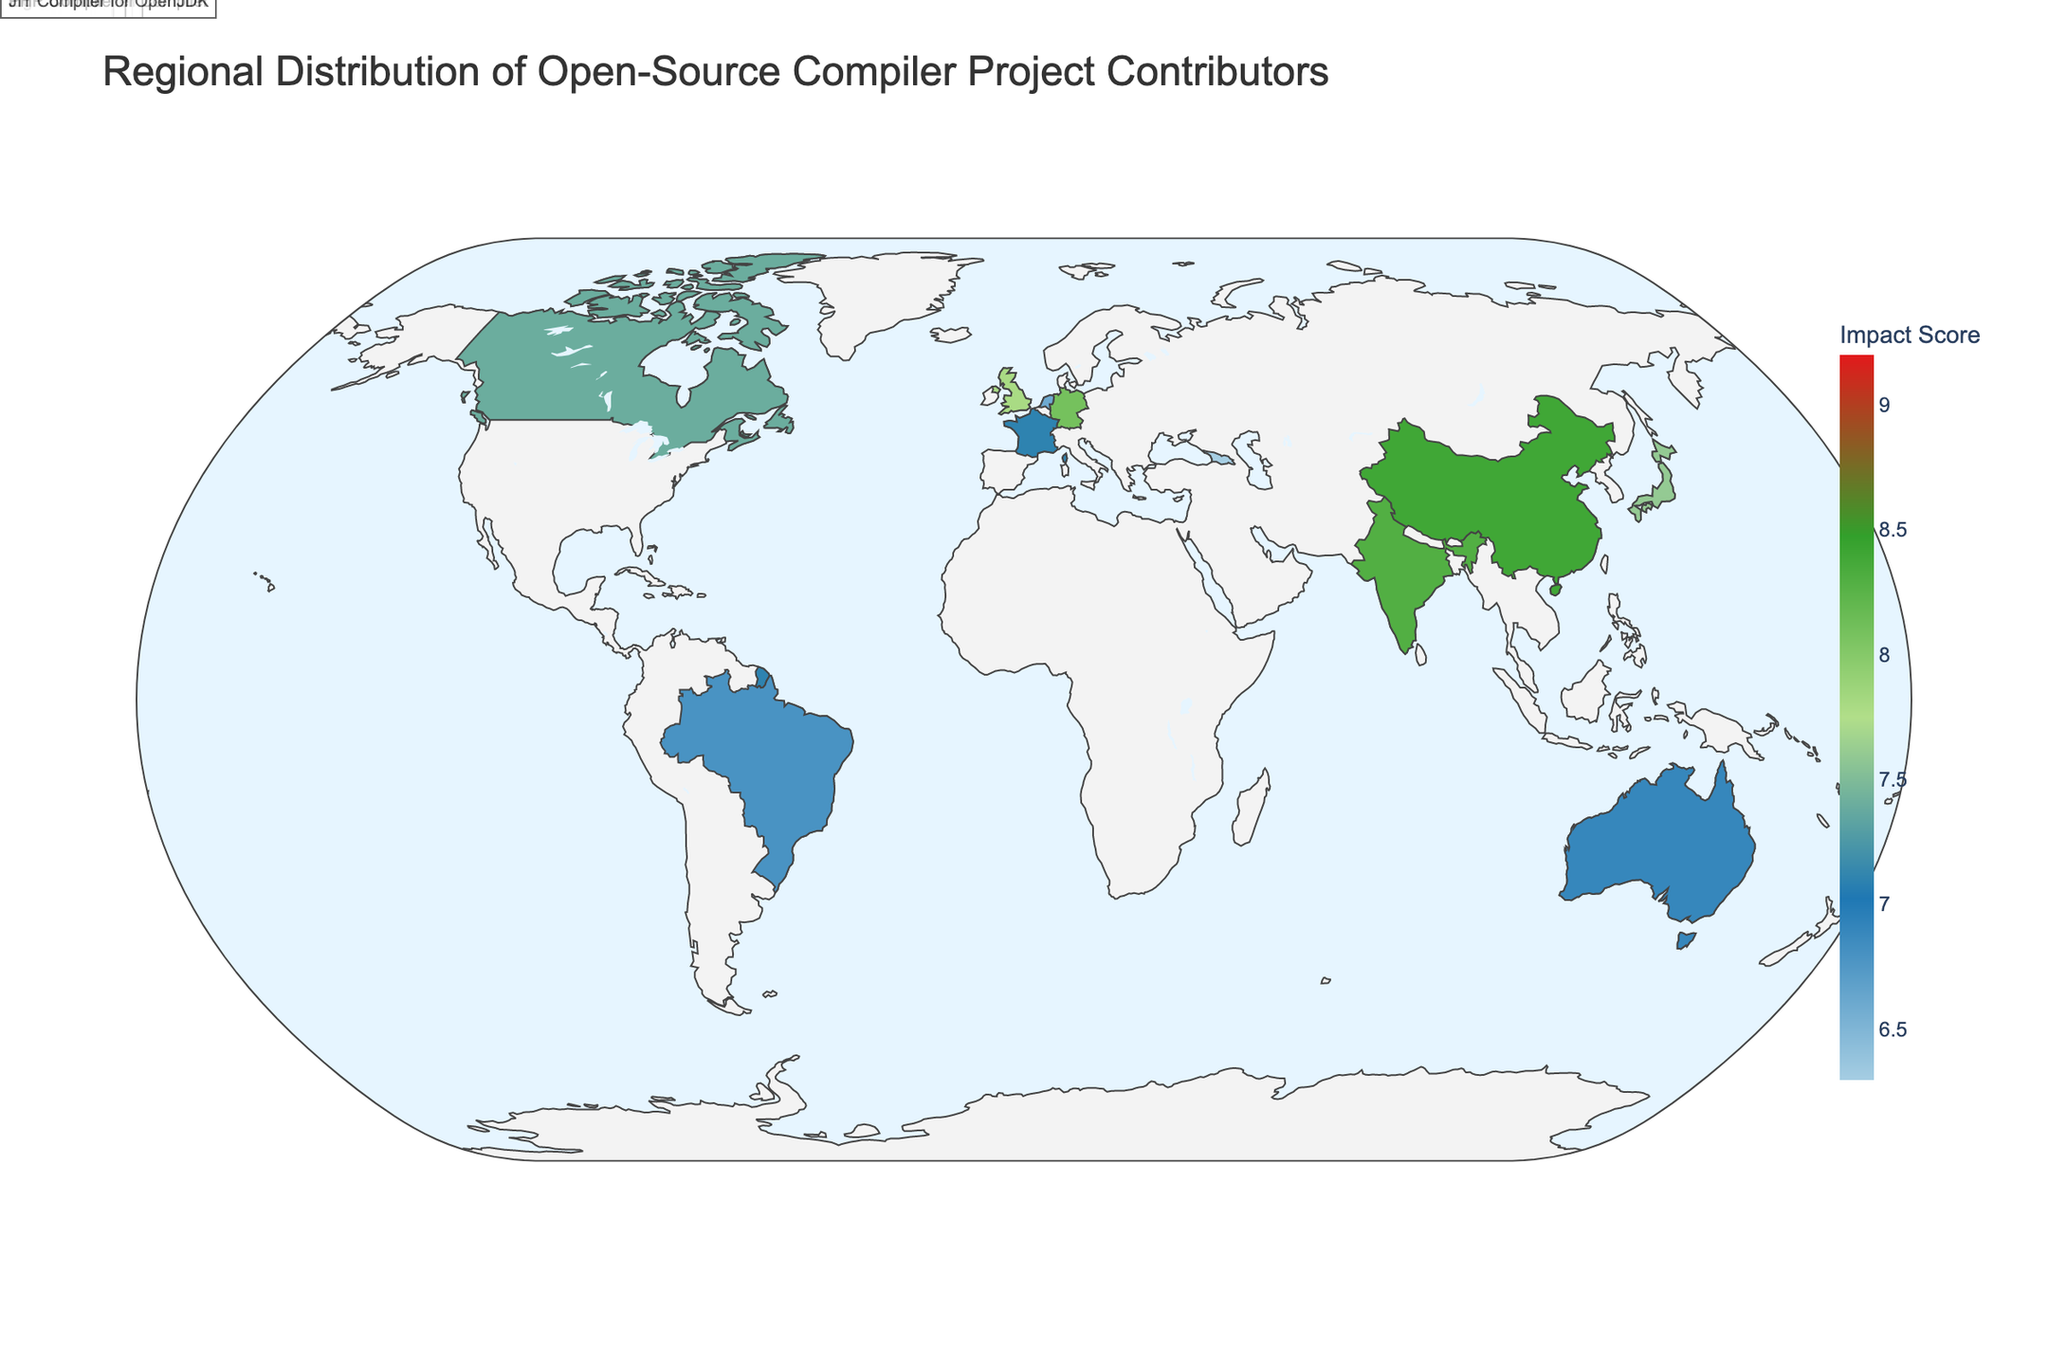What's the region with the highest number of contributors? The figure shows the number of contributors for each region. By identifying the highest value among these numbers, we see that California has the highest with 1250 contributors.
Answer: California Which region has the lowest impact score? By looking at the impact scores for each region, we can see that Georgia has the lowest impact score of 6.3.
Answer: Georgia How does the number of contributors in California compare to India? California has 1250 contributors, while India has 1100. Therefore, California has more contributors than India.
Answer: California has more What is the average impact score of regions in the United States? The regions in the United States listed are California (9.2), New York (8.5), Washington (8.8), Massachusetts (7.9), Texas (7.2), Illinois (6.8), Oregon (7.5), North Carolina (6.5), Colorado (6.7), and Georgia (6.3). Adding these and dividing by the number of regions (10) gives the average: (9.2 + 8.5 + 8.8 + 7.9 + 7.2 + 6.8 + 7.5 + 6.5 + 6.7 + 6.3) / 10 = 75.4 / 10 = 7.54.
Answer: 7.54 Which region is associated with the LLVM project and what is its impact score? The LLVM project is associated with California, which has an impact score of 9.2.
Answer: 9.2 What is the total number of contributors in Germany and the United Kingdom? Germany has 850 contributors, and the United Kingdom has 720 contributors. Adding these together gives 850 + 720 = 1570 contributors.
Answer: 1570 Which region outside of the United States has the highest impact score and which project is it associated with? The regions outside of the United States with their impact scores need to be compared. India has the highest with an impact score of 8.3, and it is associated with the GraalVM project.
Answer: India (GraalVM) Are there more contributors in Colorado or Netherlands, and what's the difference? Colorado has 330 contributors, and Netherlands has 290 contributors. Therefore, Colorado has more contributors. The difference is 330 - 290 = 40.
Answer: Colorado, 40 What's the median impact score of the regions listed? To find the median impact score, list the scores in order: 6.3, 6.5, 6.6, 6.7, 6.8, 6.8, 6.9, 7.1, 7.2, 7.4, 7.5, 7.6, 7.8, 7.9, 8.1, 8.3, 8.4, 8.5, 8.8, 9.2. Since there are 20 regions, the median will be the average of the 10th and 11th scores: (7.4 + 7.5) / 2 = 7.45.
Answer: 7.45 How many countries have an impact score of 7 or higher? The impact scores 7 or higher are: California (9.2), New York (8.5), Washington (8.8), Massachusetts (7.9), Texas (7.2), Oregon (7.5), India (8.3), Germany (8.1), United Kingdom (7.8), China (8.4), Japan (7.6), France (7.1), Canada (7.4), Australia (6.9), Netherlands (6.6), and Brazil (6.8). By counting, there are 13 countries with an impact score of 7 or higher.
Answer: 13 